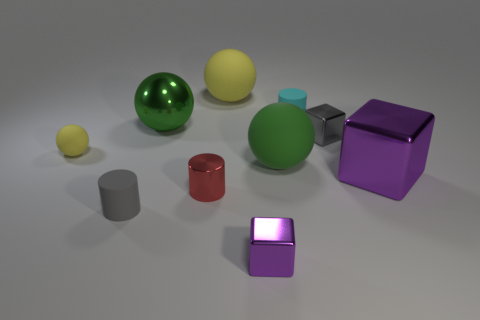Subtract all cyan spheres. Subtract all brown cubes. How many spheres are left? 4 Subtract all spheres. How many objects are left? 6 Subtract 0 brown spheres. How many objects are left? 10 Subtract all gray rubber cylinders. Subtract all small rubber spheres. How many objects are left? 8 Add 6 small gray metal blocks. How many small gray metal blocks are left? 7 Add 6 large brown matte cylinders. How many large brown matte cylinders exist? 6 